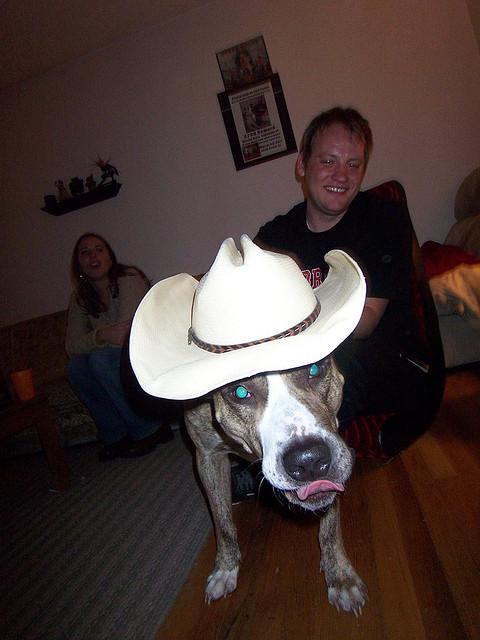Why are the dogs eyes green?
Answer briefly. Light. What color is the hat band?
Answer briefly. Brown. What is the dog wearing?
Concise answer only. Cowboy hat. 